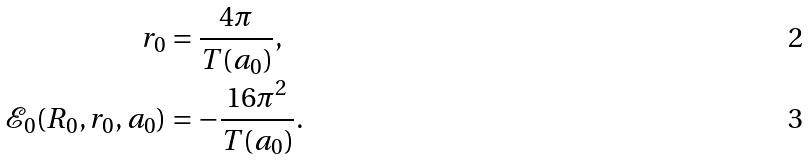Convert formula to latex. <formula><loc_0><loc_0><loc_500><loc_500>r _ { 0 } & = \frac { 4 \pi } { T ( a _ { 0 } ) } , \\ \mathcal { E } _ { 0 } ( R _ { 0 } , r _ { 0 } , a _ { 0 } ) & = - \frac { 1 6 \pi ^ { 2 } } { T ( a _ { 0 } ) } .</formula> 